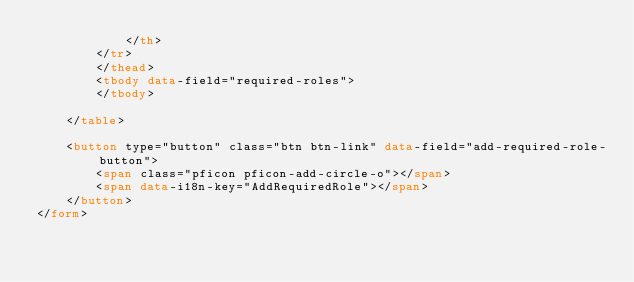<code> <loc_0><loc_0><loc_500><loc_500><_HTML_>            </th>
        </tr>
        </thead>
        <tbody data-field="required-roles">
        </tbody>

    </table>

    <button type="button" class="btn btn-link" data-field="add-required-role-button">
        <span class="pficon pficon-add-circle-o"></span>
        <span data-i18n-key="AddRequiredRole"></span>
    </button>
</form></code> 